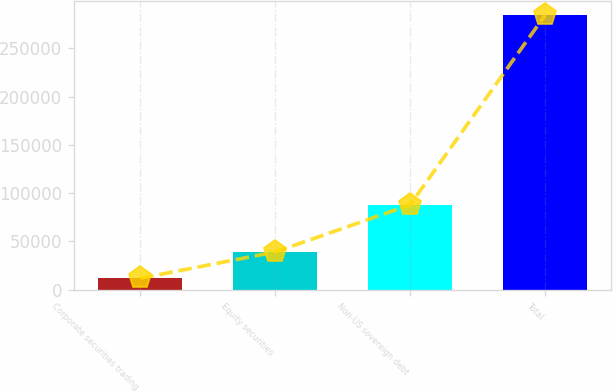<chart> <loc_0><loc_0><loc_500><loc_500><bar_chart><fcel>Corporate securities trading<fcel>Equity securities<fcel>Non-US sovereign debt<fcel>Total<nl><fcel>11767<fcel>39020.6<fcel>87849<fcel>284303<nl></chart> 